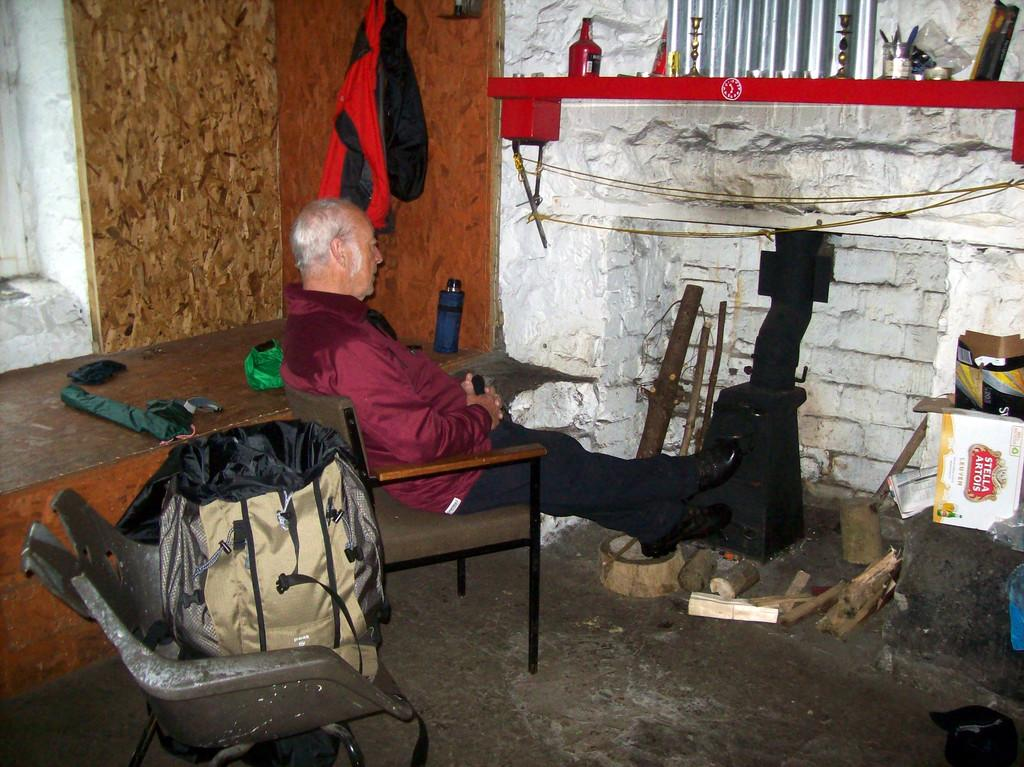What is the person in the image doing? The person is sitting in a chair. What object is present in the image that is typically used for eating or working on? There is a table in the image. What object is present in the image that provides shade or protection from the sun or rain? There is an umbrella in the image. What is on the table in the image? There is some cloth on the table. What can be seen in the background of the image? There is a wall, a bottle, and a roof shield in the background of the image. What type of parcel is being delivered to the group of people in the image? There is no group of people or parcel present in the image. 